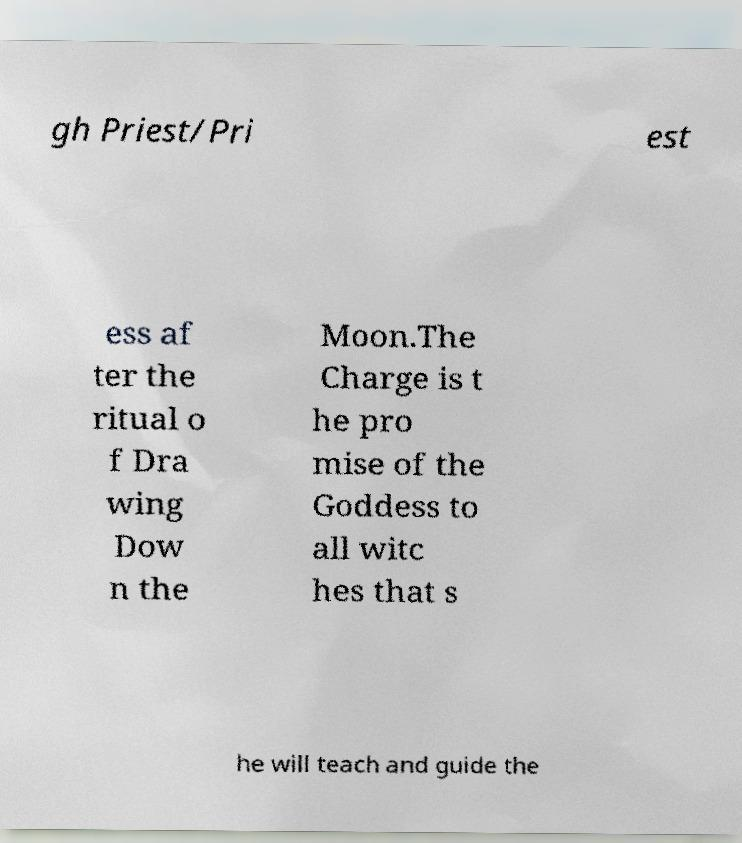Please identify and transcribe the text found in this image. gh Priest/Pri est ess af ter the ritual o f Dra wing Dow n the Moon.The Charge is t he pro mise of the Goddess to all witc hes that s he will teach and guide the 